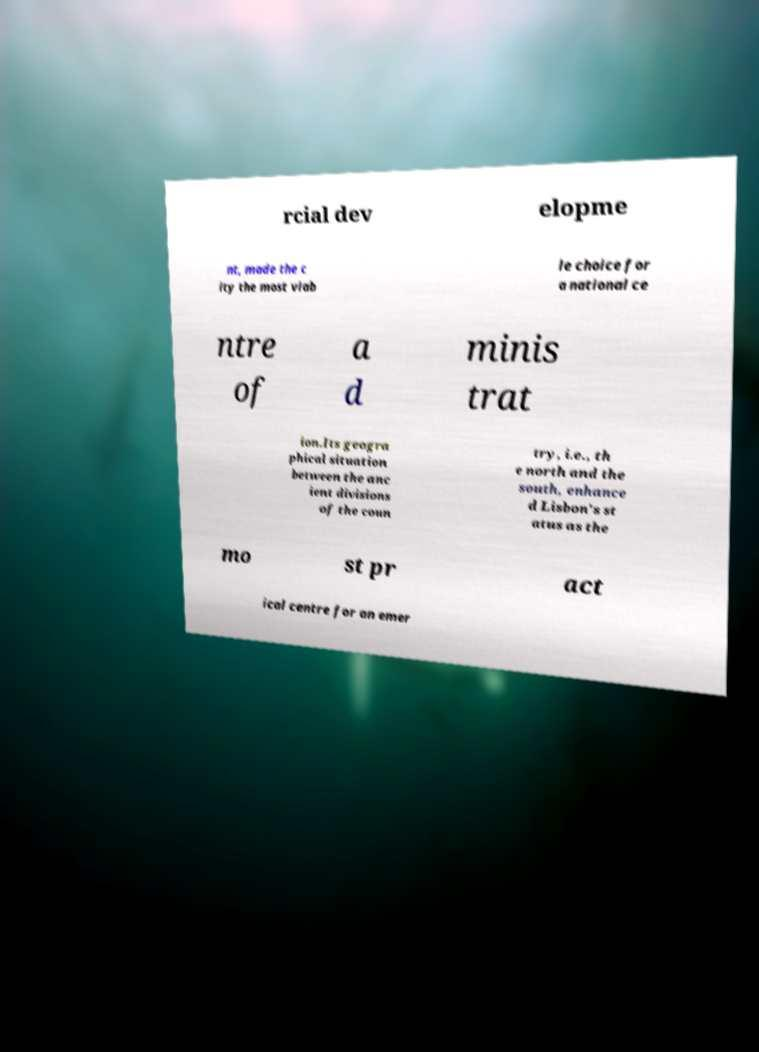Can you read and provide the text displayed in the image?This photo seems to have some interesting text. Can you extract and type it out for me? rcial dev elopme nt, made the c ity the most viab le choice for a national ce ntre of a d minis trat ion.Its geogra phical situation between the anc ient divisions of the coun try, i.e., th e north and the south, enhance d Lisbon's st atus as the mo st pr act ical centre for an emer 